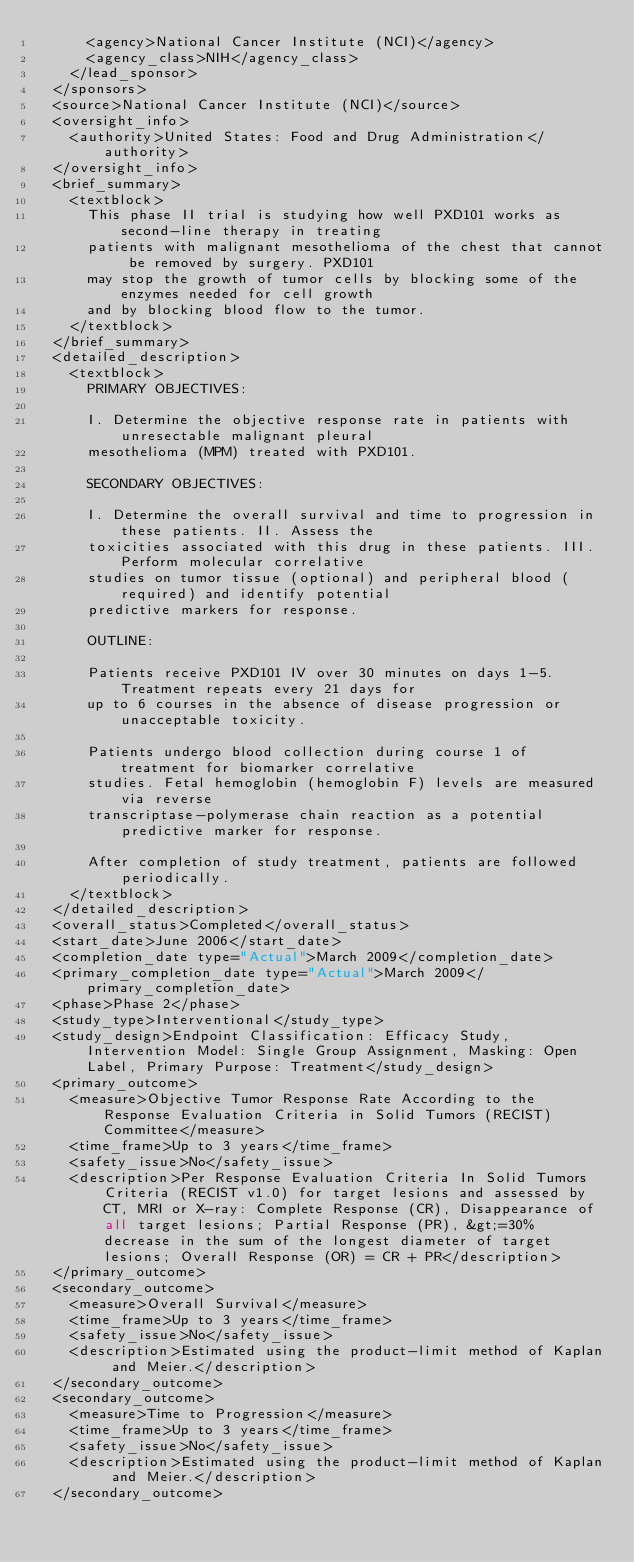Convert code to text. <code><loc_0><loc_0><loc_500><loc_500><_XML_>      <agency>National Cancer Institute (NCI)</agency>
      <agency_class>NIH</agency_class>
    </lead_sponsor>
  </sponsors>
  <source>National Cancer Institute (NCI)</source>
  <oversight_info>
    <authority>United States: Food and Drug Administration</authority>
  </oversight_info>
  <brief_summary>
    <textblock>
      This phase II trial is studying how well PXD101 works as second-line therapy in treating
      patients with malignant mesothelioma of the chest that cannot be removed by surgery. PXD101
      may stop the growth of tumor cells by blocking some of the enzymes needed for cell growth
      and by blocking blood flow to the tumor.
    </textblock>
  </brief_summary>
  <detailed_description>
    <textblock>
      PRIMARY OBJECTIVES:

      I. Determine the objective response rate in patients with unresectable malignant pleural
      mesothelioma (MPM) treated with PXD101.

      SECONDARY OBJECTIVES:

      I. Determine the overall survival and time to progression in these patients. II. Assess the
      toxicities associated with this drug in these patients. III. Perform molecular correlative
      studies on tumor tissue (optional) and peripheral blood (required) and identify potential
      predictive markers for response.

      OUTLINE:

      Patients receive PXD101 IV over 30 minutes on days 1-5. Treatment repeats every 21 days for
      up to 6 courses in the absence of disease progression or unacceptable toxicity.

      Patients undergo blood collection during course 1 of treatment for biomarker correlative
      studies. Fetal hemoglobin (hemoglobin F) levels are measured via reverse
      transcriptase-polymerase chain reaction as a potential predictive marker for response.

      After completion of study treatment, patients are followed periodically.
    </textblock>
  </detailed_description>
  <overall_status>Completed</overall_status>
  <start_date>June 2006</start_date>
  <completion_date type="Actual">March 2009</completion_date>
  <primary_completion_date type="Actual">March 2009</primary_completion_date>
  <phase>Phase 2</phase>
  <study_type>Interventional</study_type>
  <study_design>Endpoint Classification: Efficacy Study, Intervention Model: Single Group Assignment, Masking: Open Label, Primary Purpose: Treatment</study_design>
  <primary_outcome>
    <measure>Objective Tumor Response Rate According to the Response Evaluation Criteria in Solid Tumors (RECIST) Committee</measure>
    <time_frame>Up to 3 years</time_frame>
    <safety_issue>No</safety_issue>
    <description>Per Response Evaluation Criteria In Solid Tumors Criteria (RECIST v1.0) for target lesions and assessed by CT, MRI or X-ray: Complete Response (CR), Disappearance of all target lesions; Partial Response (PR), &gt;=30% decrease in the sum of the longest diameter of target lesions; Overall Response (OR) = CR + PR</description>
  </primary_outcome>
  <secondary_outcome>
    <measure>Overall Survival</measure>
    <time_frame>Up to 3 years</time_frame>
    <safety_issue>No</safety_issue>
    <description>Estimated using the product-limit method of Kaplan and Meier.</description>
  </secondary_outcome>
  <secondary_outcome>
    <measure>Time to Progression</measure>
    <time_frame>Up to 3 years</time_frame>
    <safety_issue>No</safety_issue>
    <description>Estimated using the product-limit method of Kaplan and Meier.</description>
  </secondary_outcome></code> 